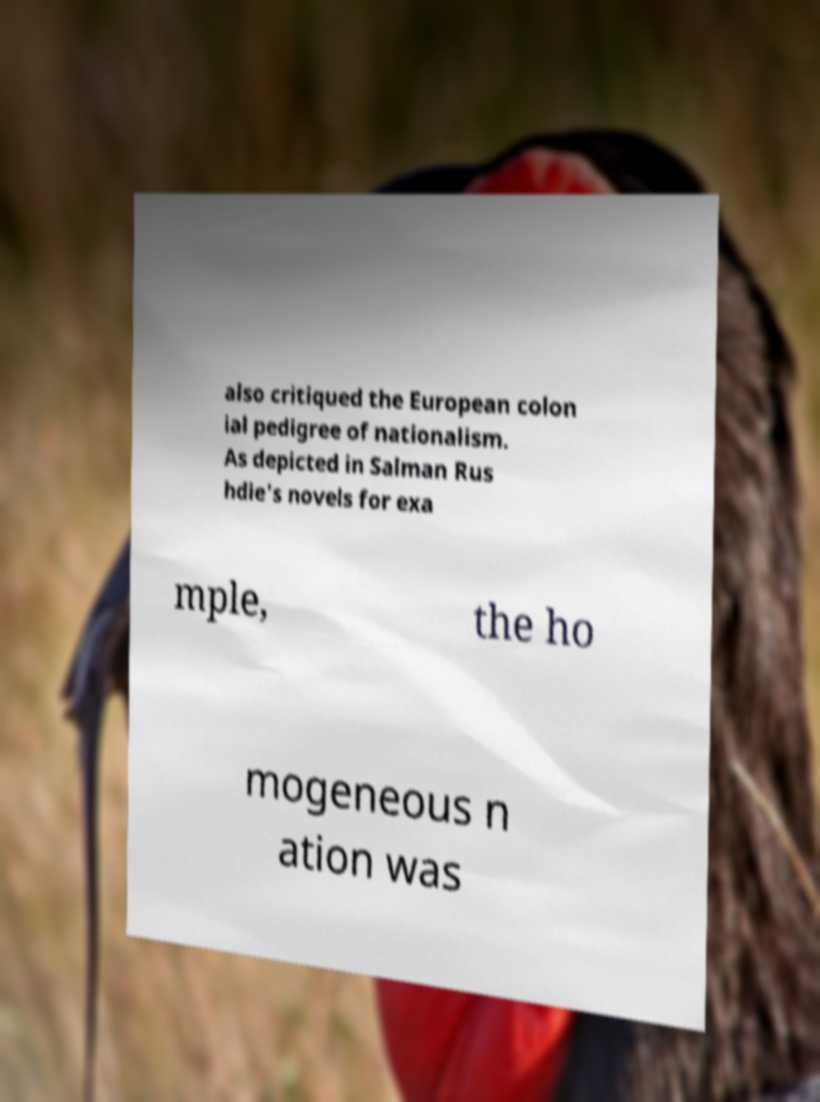There's text embedded in this image that I need extracted. Can you transcribe it verbatim? also critiqued the European colon ial pedigree of nationalism. As depicted in Salman Rus hdie's novels for exa mple, the ho mogeneous n ation was 